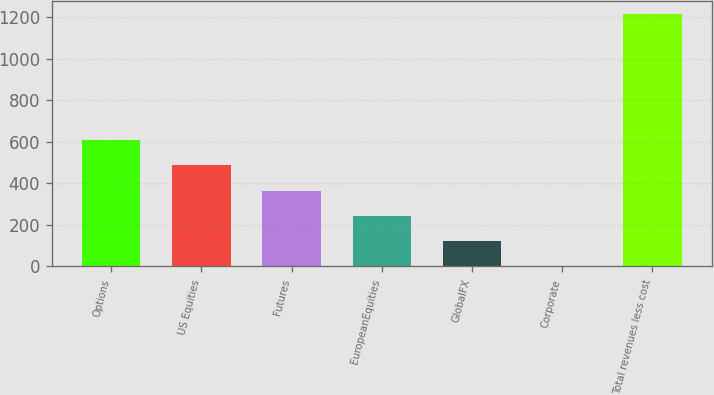Convert chart. <chart><loc_0><loc_0><loc_500><loc_500><bar_chart><fcel>Options<fcel>US Equities<fcel>Futures<fcel>EuropeanEquities<fcel>GlobalFX<fcel>Corporate<fcel>Total revenues less cost<nl><fcel>611.2<fcel>487<fcel>365.35<fcel>243.7<fcel>122.05<fcel>0.4<fcel>1216.9<nl></chart> 